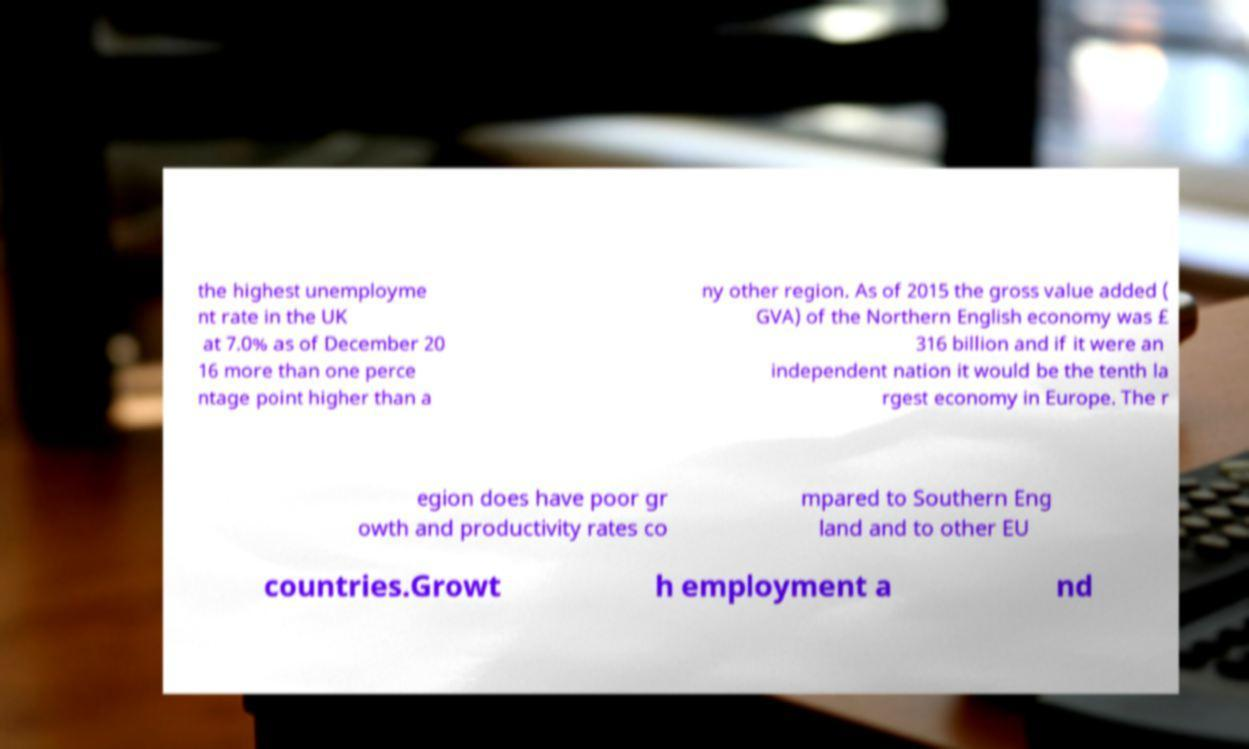Can you accurately transcribe the text from the provided image for me? the highest unemployme nt rate in the UK at 7.0% as of December 20 16 more than one perce ntage point higher than a ny other region. As of 2015 the gross value added ( GVA) of the Northern English economy was £ 316 billion and if it were an independent nation it would be the tenth la rgest economy in Europe. The r egion does have poor gr owth and productivity rates co mpared to Southern Eng land and to other EU countries.Growt h employment a nd 